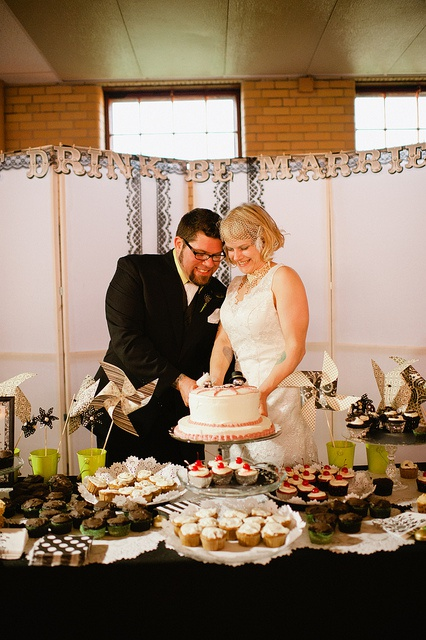Describe the objects in this image and their specific colors. I can see dining table in maroon, black, beige, olive, and tan tones, cake in maroon, black, lightgray, and tan tones, people in maroon, black, and tan tones, people in maroon, tan, and ivory tones, and cake in maroon, beige, and tan tones in this image. 